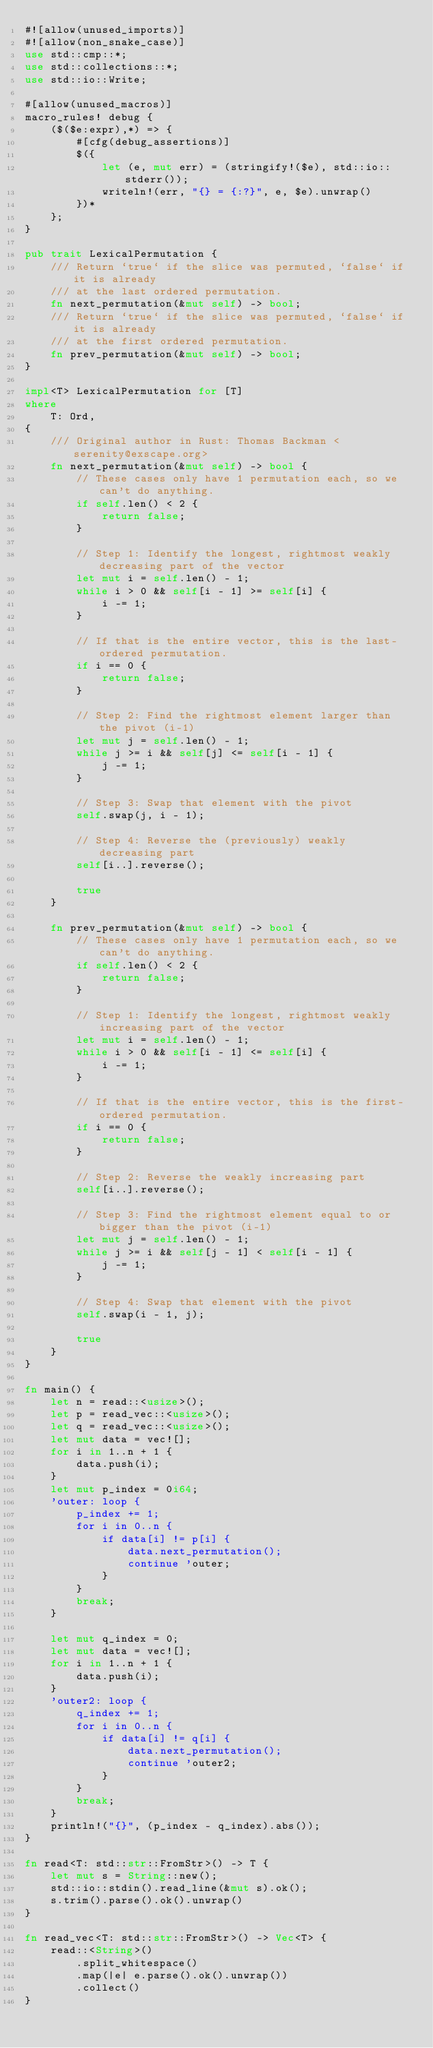Convert code to text. <code><loc_0><loc_0><loc_500><loc_500><_Rust_>#![allow(unused_imports)]
#![allow(non_snake_case)]
use std::cmp::*;
use std::collections::*;
use std::io::Write;

#[allow(unused_macros)]
macro_rules! debug {
    ($($e:expr),*) => {
        #[cfg(debug_assertions)]
        $({
            let (e, mut err) = (stringify!($e), std::io::stderr());
            writeln!(err, "{} = {:?}", e, $e).unwrap()
        })*
    };
}

pub trait LexicalPermutation {
    /// Return `true` if the slice was permuted, `false` if it is already
    /// at the last ordered permutation.
    fn next_permutation(&mut self) -> bool;
    /// Return `true` if the slice was permuted, `false` if it is already
    /// at the first ordered permutation.
    fn prev_permutation(&mut self) -> bool;
}

impl<T> LexicalPermutation for [T]
where
    T: Ord,
{
    /// Original author in Rust: Thomas Backman <serenity@exscape.org>
    fn next_permutation(&mut self) -> bool {
        // These cases only have 1 permutation each, so we can't do anything.
        if self.len() < 2 {
            return false;
        }

        // Step 1: Identify the longest, rightmost weakly decreasing part of the vector
        let mut i = self.len() - 1;
        while i > 0 && self[i - 1] >= self[i] {
            i -= 1;
        }

        // If that is the entire vector, this is the last-ordered permutation.
        if i == 0 {
            return false;
        }

        // Step 2: Find the rightmost element larger than the pivot (i-1)
        let mut j = self.len() - 1;
        while j >= i && self[j] <= self[i - 1] {
            j -= 1;
        }

        // Step 3: Swap that element with the pivot
        self.swap(j, i - 1);

        // Step 4: Reverse the (previously) weakly decreasing part
        self[i..].reverse();

        true
    }

    fn prev_permutation(&mut self) -> bool {
        // These cases only have 1 permutation each, so we can't do anything.
        if self.len() < 2 {
            return false;
        }

        // Step 1: Identify the longest, rightmost weakly increasing part of the vector
        let mut i = self.len() - 1;
        while i > 0 && self[i - 1] <= self[i] {
            i -= 1;
        }

        // If that is the entire vector, this is the first-ordered permutation.
        if i == 0 {
            return false;
        }

        // Step 2: Reverse the weakly increasing part
        self[i..].reverse();

        // Step 3: Find the rightmost element equal to or bigger than the pivot (i-1)
        let mut j = self.len() - 1;
        while j >= i && self[j - 1] < self[i - 1] {
            j -= 1;
        }

        // Step 4: Swap that element with the pivot
        self.swap(i - 1, j);

        true
    }
}

fn main() {
    let n = read::<usize>();
    let p = read_vec::<usize>();
    let q = read_vec::<usize>();
    let mut data = vec![];
    for i in 1..n + 1 {
        data.push(i);
    }
    let mut p_index = 0i64;
    'outer: loop {
        p_index += 1;
        for i in 0..n {
            if data[i] != p[i] {
                data.next_permutation();
                continue 'outer;
            }
        }
        break;
    }

    let mut q_index = 0;
    let mut data = vec![];
    for i in 1..n + 1 {
        data.push(i);
    }
    'outer2: loop {
        q_index += 1;
        for i in 0..n {
            if data[i] != q[i] {
                data.next_permutation();
                continue 'outer2;
            }
        }
        break;
    }
    println!("{}", (p_index - q_index).abs());
}

fn read<T: std::str::FromStr>() -> T {
    let mut s = String::new();
    std::io::stdin().read_line(&mut s).ok();
    s.trim().parse().ok().unwrap()
}

fn read_vec<T: std::str::FromStr>() -> Vec<T> {
    read::<String>()
        .split_whitespace()
        .map(|e| e.parse().ok().unwrap())
        .collect()
}
</code> 